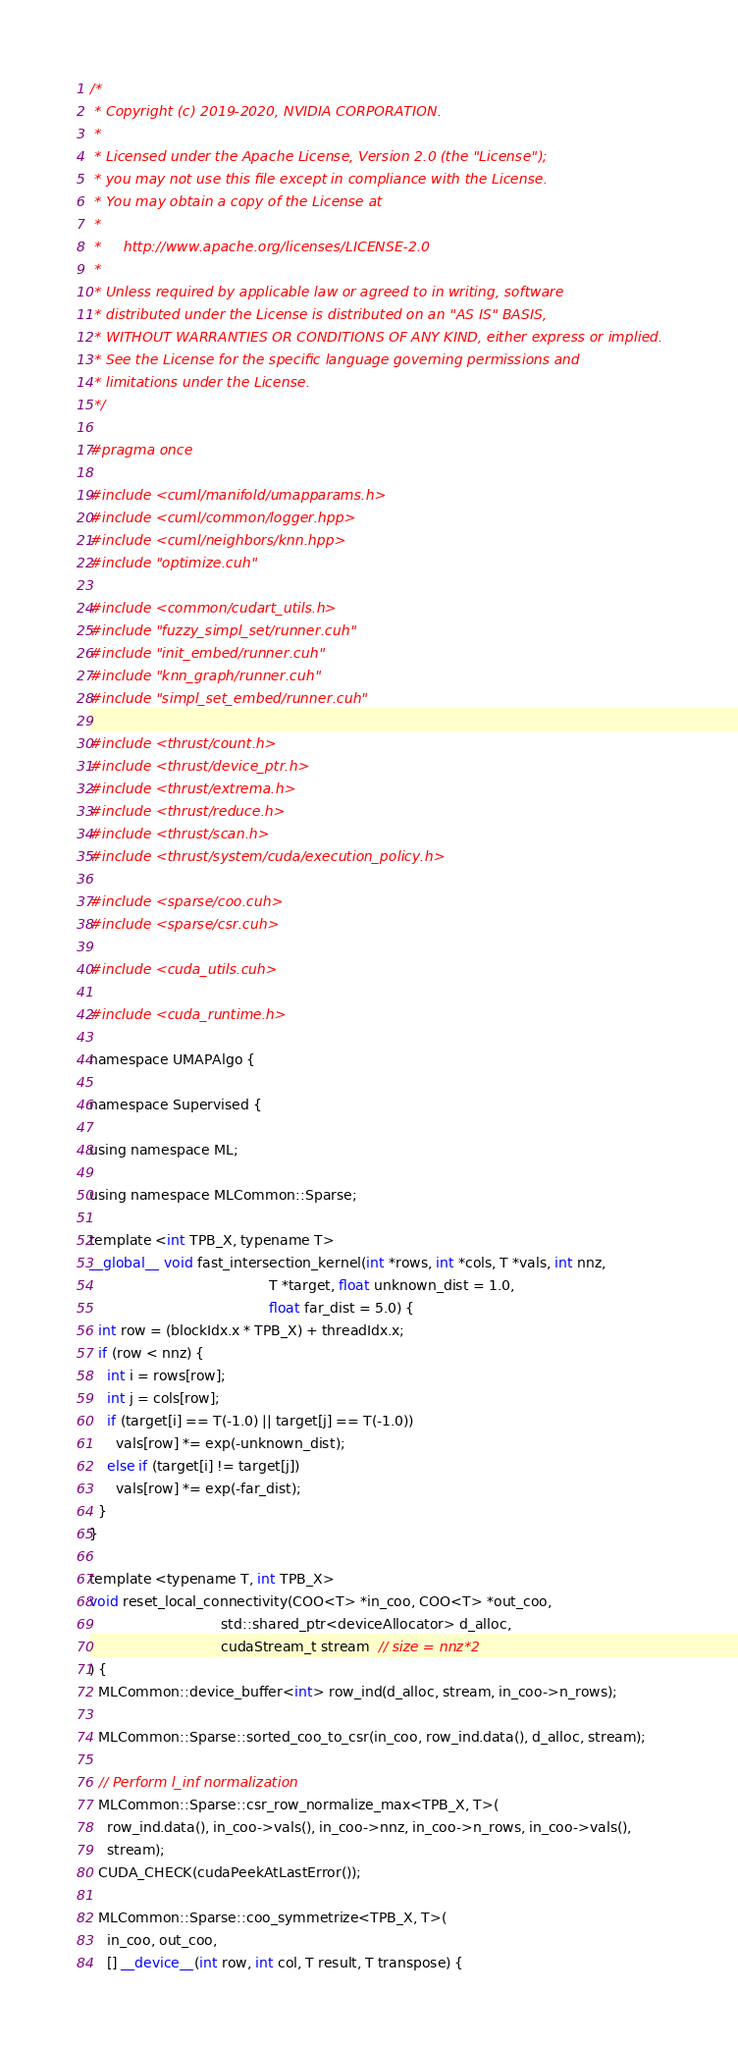<code> <loc_0><loc_0><loc_500><loc_500><_Cuda_>/*
 * Copyright (c) 2019-2020, NVIDIA CORPORATION.
 *
 * Licensed under the Apache License, Version 2.0 (the "License");
 * you may not use this file except in compliance with the License.
 * You may obtain a copy of the License at
 *
 *     http://www.apache.org/licenses/LICENSE-2.0
 *
 * Unless required by applicable law or agreed to in writing, software
 * distributed under the License is distributed on an "AS IS" BASIS,
 * WITHOUT WARRANTIES OR CONDITIONS OF ANY KIND, either express or implied.
 * See the License for the specific language governing permissions and
 * limitations under the License.
 */

#pragma once

#include <cuml/manifold/umapparams.h>
#include <cuml/common/logger.hpp>
#include <cuml/neighbors/knn.hpp>
#include "optimize.cuh"

#include <common/cudart_utils.h>
#include "fuzzy_simpl_set/runner.cuh"
#include "init_embed/runner.cuh"
#include "knn_graph/runner.cuh"
#include "simpl_set_embed/runner.cuh"

#include <thrust/count.h>
#include <thrust/device_ptr.h>
#include <thrust/extrema.h>
#include <thrust/reduce.h>
#include <thrust/scan.h>
#include <thrust/system/cuda/execution_policy.h>

#include <sparse/coo.cuh>
#include <sparse/csr.cuh>

#include <cuda_utils.cuh>

#include <cuda_runtime.h>

namespace UMAPAlgo {

namespace Supervised {

using namespace ML;

using namespace MLCommon::Sparse;

template <int TPB_X, typename T>
__global__ void fast_intersection_kernel(int *rows, int *cols, T *vals, int nnz,
                                         T *target, float unknown_dist = 1.0,
                                         float far_dist = 5.0) {
  int row = (blockIdx.x * TPB_X) + threadIdx.x;
  if (row < nnz) {
    int i = rows[row];
    int j = cols[row];
    if (target[i] == T(-1.0) || target[j] == T(-1.0))
      vals[row] *= exp(-unknown_dist);
    else if (target[i] != target[j])
      vals[row] *= exp(-far_dist);
  }
}

template <typename T, int TPB_X>
void reset_local_connectivity(COO<T> *in_coo, COO<T> *out_coo,
                              std::shared_ptr<deviceAllocator> d_alloc,
                              cudaStream_t stream  // size = nnz*2
) {
  MLCommon::device_buffer<int> row_ind(d_alloc, stream, in_coo->n_rows);

  MLCommon::Sparse::sorted_coo_to_csr(in_coo, row_ind.data(), d_alloc, stream);

  // Perform l_inf normalization
  MLCommon::Sparse::csr_row_normalize_max<TPB_X, T>(
    row_ind.data(), in_coo->vals(), in_coo->nnz, in_coo->n_rows, in_coo->vals(),
    stream);
  CUDA_CHECK(cudaPeekAtLastError());

  MLCommon::Sparse::coo_symmetrize<TPB_X, T>(
    in_coo, out_coo,
    [] __device__(int row, int col, T result, T transpose) {</code> 